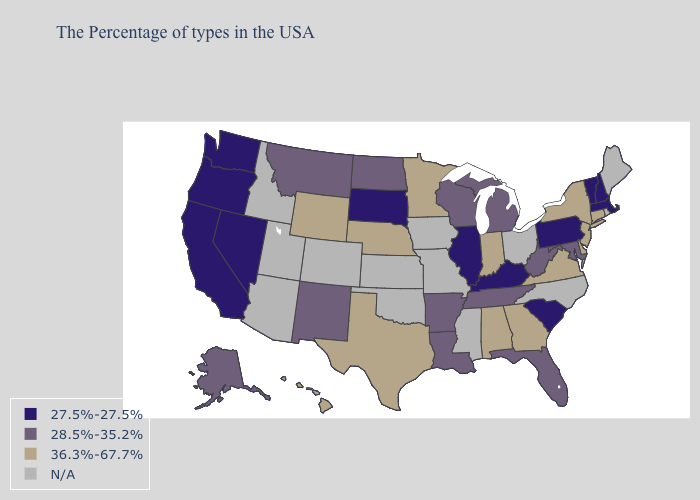Among the states that border Kentucky , does West Virginia have the highest value?
Keep it brief. No. What is the value of West Virginia?
Give a very brief answer. 28.5%-35.2%. Among the states that border Indiana , does Michigan have the lowest value?
Answer briefly. No. Name the states that have a value in the range N/A?
Be succinct. Maine, Rhode Island, North Carolina, Ohio, Mississippi, Missouri, Iowa, Kansas, Oklahoma, Colorado, Utah, Arizona, Idaho. Which states hav the highest value in the South?
Short answer required. Delaware, Virginia, Georgia, Alabama, Texas. Does Washington have the lowest value in the USA?
Concise answer only. Yes. Does Kentucky have the highest value in the USA?
Write a very short answer. No. Name the states that have a value in the range 28.5%-35.2%?
Give a very brief answer. Maryland, West Virginia, Florida, Michigan, Tennessee, Wisconsin, Louisiana, Arkansas, North Dakota, New Mexico, Montana, Alaska. What is the value of Oregon?
Concise answer only. 27.5%-27.5%. What is the highest value in the USA?
Write a very short answer. 36.3%-67.7%. What is the value of Wisconsin?
Keep it brief. 28.5%-35.2%. What is the value of West Virginia?
Give a very brief answer. 28.5%-35.2%. Among the states that border Nebraska , does South Dakota have the lowest value?
Keep it brief. Yes. Among the states that border South Dakota , which have the highest value?
Answer briefly. Minnesota, Nebraska, Wyoming. Does Hawaii have the highest value in the West?
Write a very short answer. Yes. 